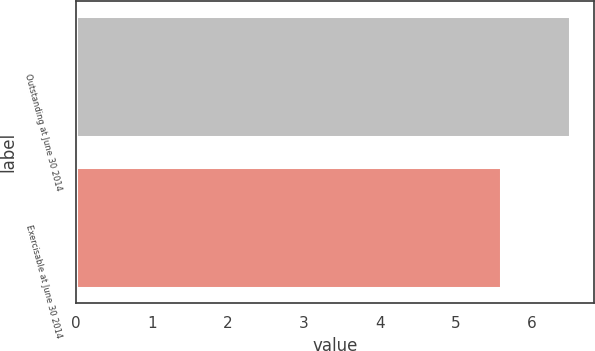Convert chart to OTSL. <chart><loc_0><loc_0><loc_500><loc_500><bar_chart><fcel>Outstanding at June 30 2014<fcel>Exercisable at June 30 2014<nl><fcel>6.5<fcel>5.6<nl></chart> 